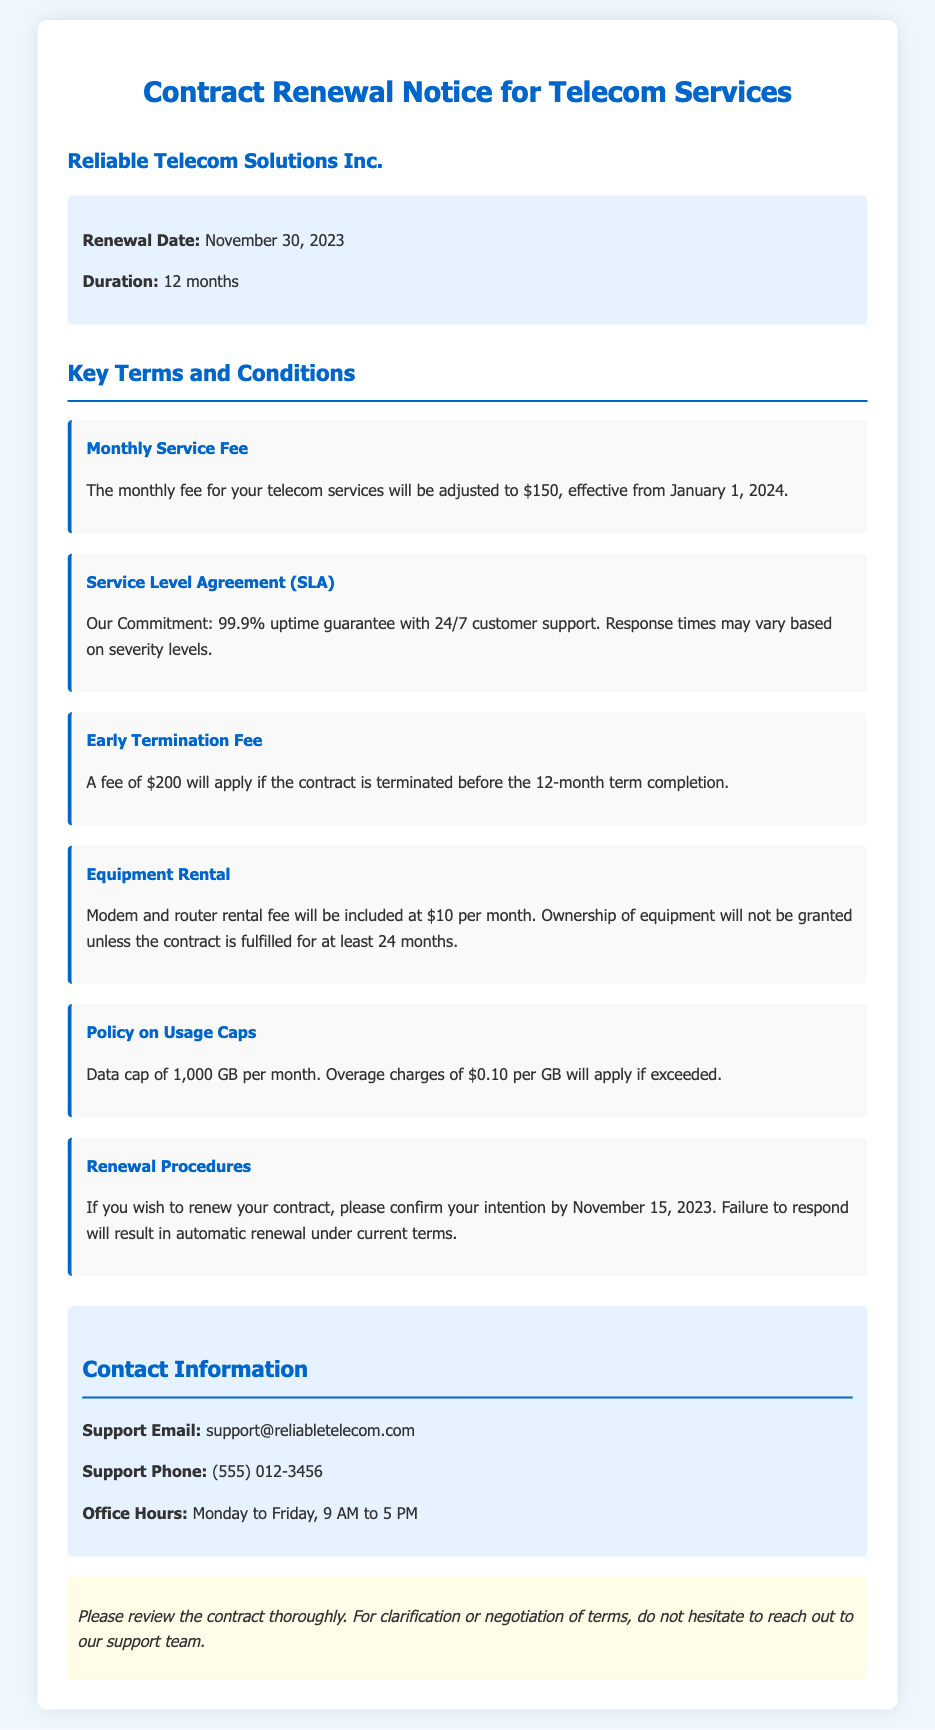What is the renewal date? The renewal date is mentioned in the document as the date when the contract needs to be renewed.
Answer: November 30, 2023 What is the duration of the contract? The document specifies the length of time the contract is effective after renewal.
Answer: 12 months What is the monthly service fee starting January 1, 2024? The document states the new fee that will begin at the start of the contract term following renewal.
Answer: $150 What is the early termination fee? The document provides information on the penalty for terminating the contract before the specified period.
Answer: $200 What are the operating hours for support? The document lists the times when customer support is available for assistance.
Answer: Monday to Friday, 9 AM to 5 PM What is the data cap per month? The document specifies the limit on data usage per billing cycle.
Answer: 1,000 GB What must you do to avoid automatic renewal? The document indicates the necessary action a customer must take to prevent automatic renewal of the contract.
Answer: Confirm intention by November 15, 2023 What is included in the equipment rental fee? The document details what the monthly equipment rental charge encompasses.
Answer: Modem and router rental fee What should you do for clarification or negotiation of terms? The document advises on the actions to take for any inquiries regarding contract terms.
Answer: Reach out to support team 